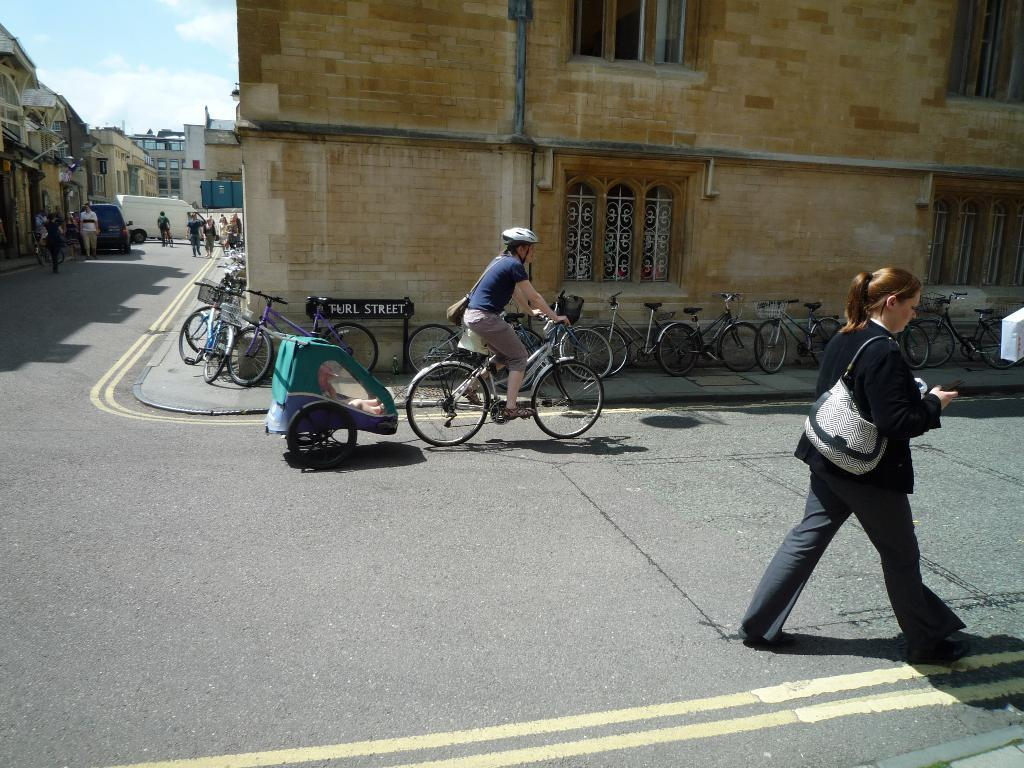What are the people in the image doing? There are people walking and riding bicycles in the image. What type of transportation can be seen in the image? Bicycles and vehicles are visible in the image. What is the setting of the image? There is a road and a building in the image. What is visible in the sky? The sky is visible in the image. How many icicles are hanging from the building in the image? There are no icicles visible in the image. What type of truck can be seen driving on the road in the image? There are no trucks visible in the image. 